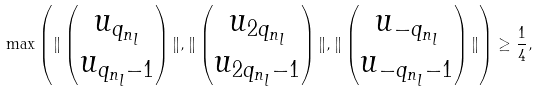<formula> <loc_0><loc_0><loc_500><loc_500>\max { \left ( \| \left ( \begin{matrix} u _ { q _ { n _ { l } } } \\ u _ { q _ { n _ { l } } - 1 } \end{matrix} \right ) \| , \| \left ( \begin{matrix} u _ { 2 q _ { n _ { l } } } \\ u _ { 2 q _ { n _ { l } } - 1 } \end{matrix} \right ) \| , \| \left ( \begin{matrix} u _ { - q _ { n _ { l } } } \\ u _ { - q _ { n _ { l } } - 1 } \end{matrix} \right ) \| \right ) } \geq \frac { 1 } { 4 } ,</formula> 